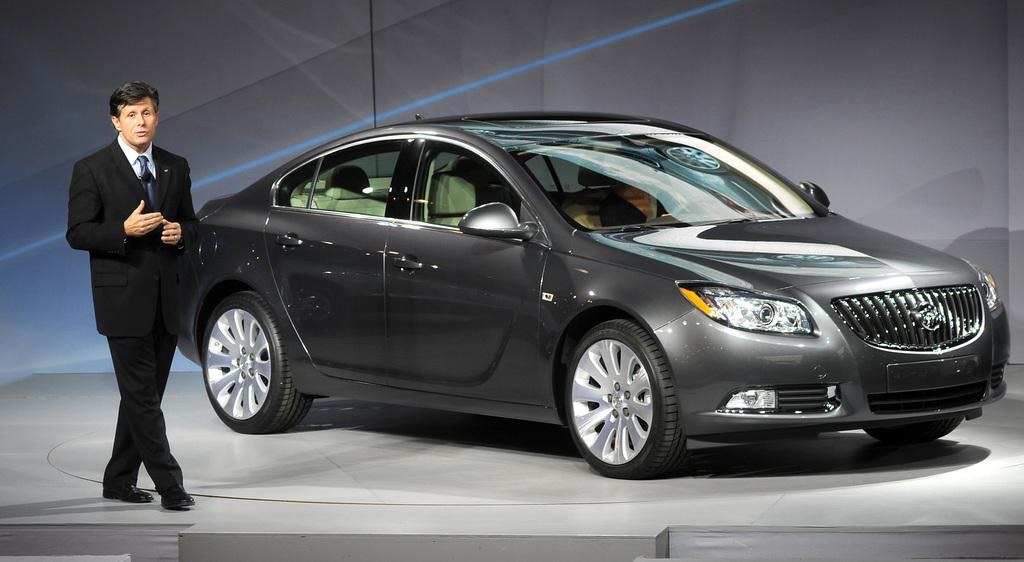What is the main subject of the image? There is a car in the image. Who or what else is present in the image? There is a man in the image. Can you describe the man's attire? The man is wearing a white suit, a white shirt, and a tie. What is the color of the background in the image? The background of the image is a grey color wall. How many wounds can be seen on the car in the image? There are no visible wounds on the car in the image. What type of ball is the man holding in the image? There is no ball present in the image. 